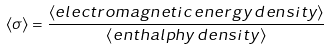Convert formula to latex. <formula><loc_0><loc_0><loc_500><loc_500>\langle \sigma \rangle = \frac { \langle e l e c t r o m a g n e t i c \, e n e r g y \, d e n s i t y \rangle } { \langle e n t h a l p h y \, d e n s i t y \rangle }</formula> 